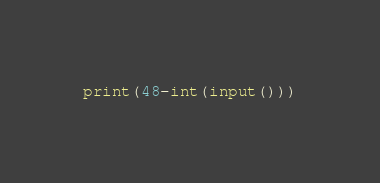Convert code to text. <code><loc_0><loc_0><loc_500><loc_500><_Python_>print(48-int(input()))


</code> 